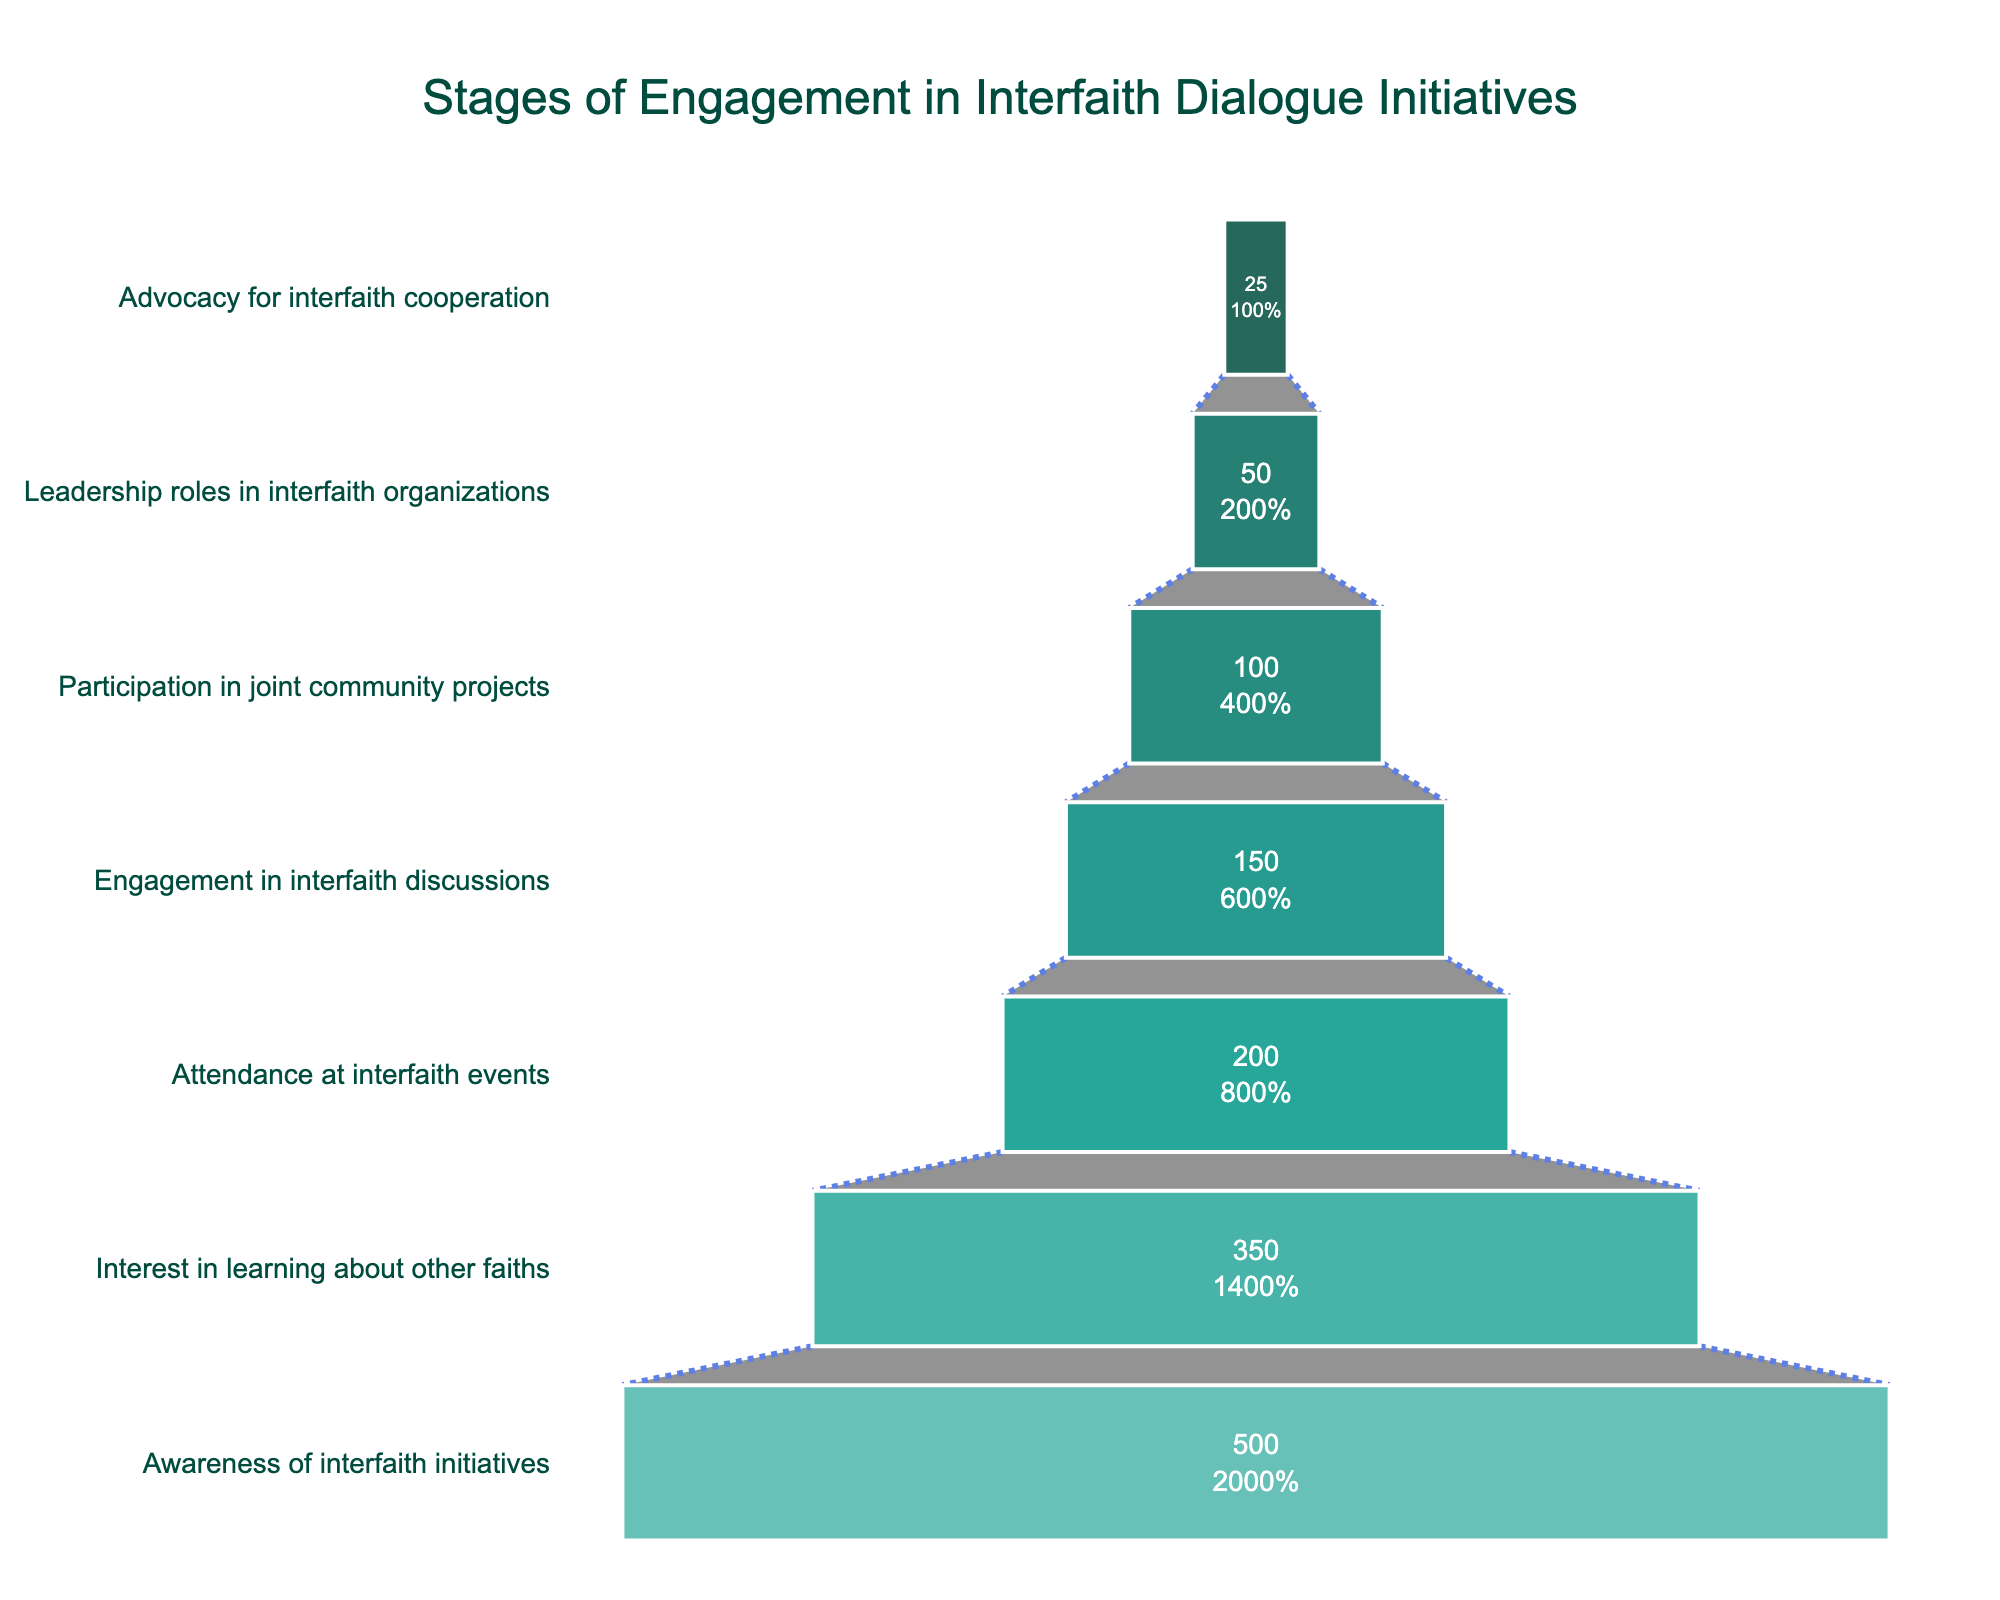What is the title of the funnel chart? The title of the funnel chart is clearly displayed at the top, describing the overall content of the visualization.
Answer: Stages of Engagement in Interfaith Dialogue Initiatives How many participants are engaged in interfaith discussions? The funnel chart lists the number of participants for each stage. For the stage "Engagement in interfaith discussions," it shows the respective participant count.
Answer: 150 How many stages are there in the funnel chart? Count the number of distinct stages listed on the y-axis of the funnel chart. Each stage represents a different level of engagement.
Answer: 7 What is the difference in participant numbers between interest in learning about other faiths and attendance at interfaith events? Subtract the number of participants at the "Attendance at interfaith events" stage from those at the "Interest in learning about other faiths" stage. This calculates the difference between the successive stages.
Answer: 150 Which stage has the highest number of participants? Look at the funnel chart and identify the stage with the largest number of participants. The initial stage of the funnel usually has the highest count.
Answer: Awareness of interfaith initiatives How many stages show a drop of more than 100 participants between consecutive stages? Calculate the participant drop between each consecutive stage. Count how many drops exceed 100 participants.
Answer: 2 What percentage of participants move from the "Attendance at interfaith events" stage to the "Engagement in interfaith discussions" stage? To find this percentage, divide the number of participants at the "Engagement in interfaith discussions" stage by the number at the previous "Attendance at interfaith events" stage, and then multiply by 100.
Answer: 75% How many more participants are there in "Participation in joint community projects" than in "Leadership roles in interfaith organizations"? Subtract the number of participants in the "Leadership roles in interfaith organizations" stage from the number in the "Participation in joint community projects" stage.
Answer: 50 At which stage do we see the most significant drop in the number of participants? Find the two consecutive stages with the largest difference in participant numbers by comparing the drop between each pair of adjacent stages.
Answer: Interest in learning about other faiths to Attendance at interfaith events What is the percentage drop from the "Engagement in interfaith discussions" stage to the "Participation in joint community projects" stage? Calculate the percentage drop by subtracting the number of participants at the later stage from the earlier stage, dividing by the earlier stage's number, and then multiplying by 100.
Answer: 33.3% 